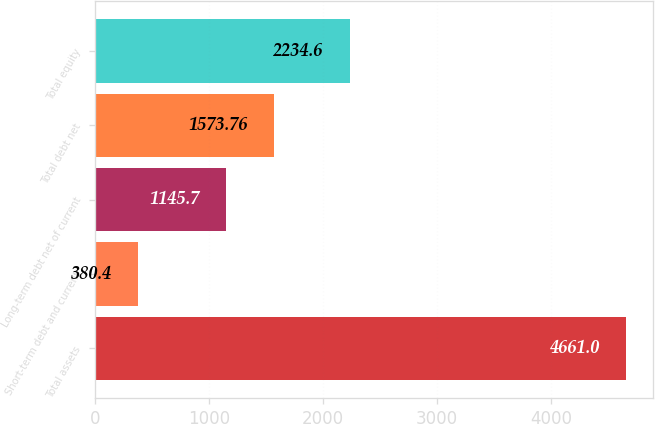Convert chart to OTSL. <chart><loc_0><loc_0><loc_500><loc_500><bar_chart><fcel>Total assets<fcel>Short-term debt and current<fcel>Long-term debt net of current<fcel>Total debt net<fcel>Total equity<nl><fcel>4661<fcel>380.4<fcel>1145.7<fcel>1573.76<fcel>2234.6<nl></chart> 